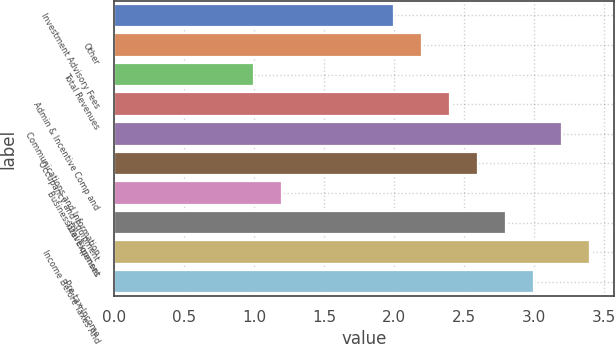Convert chart. <chart><loc_0><loc_0><loc_500><loc_500><bar_chart><fcel>Investment Advisory Fees<fcel>Other<fcel>Total Revenues<fcel>Admin & Incentive Comp and<fcel>Communications and Information<fcel>Occupancy and Equipment<fcel>Business Development<fcel>Total Expenses<fcel>Income Before Taxes And<fcel>Pre-tax Income<nl><fcel>2<fcel>2.2<fcel>1<fcel>2.4<fcel>3.2<fcel>2.6<fcel>1.2<fcel>2.8<fcel>3.4<fcel>3<nl></chart> 